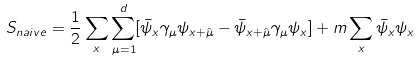Convert formula to latex. <formula><loc_0><loc_0><loc_500><loc_500>S _ { n a i v e } = \frac { 1 } { 2 } \sum _ { x } \sum _ { \mu = 1 } ^ { d } [ \bar { \psi } _ { x } \gamma _ { \mu } \psi _ { x + \hat { \mu } } - \bar { \psi } _ { x + \hat { \mu } } \gamma _ { \mu } \psi _ { x } ] + m \sum _ { x } \bar { \psi } _ { x } \psi _ { x }</formula> 